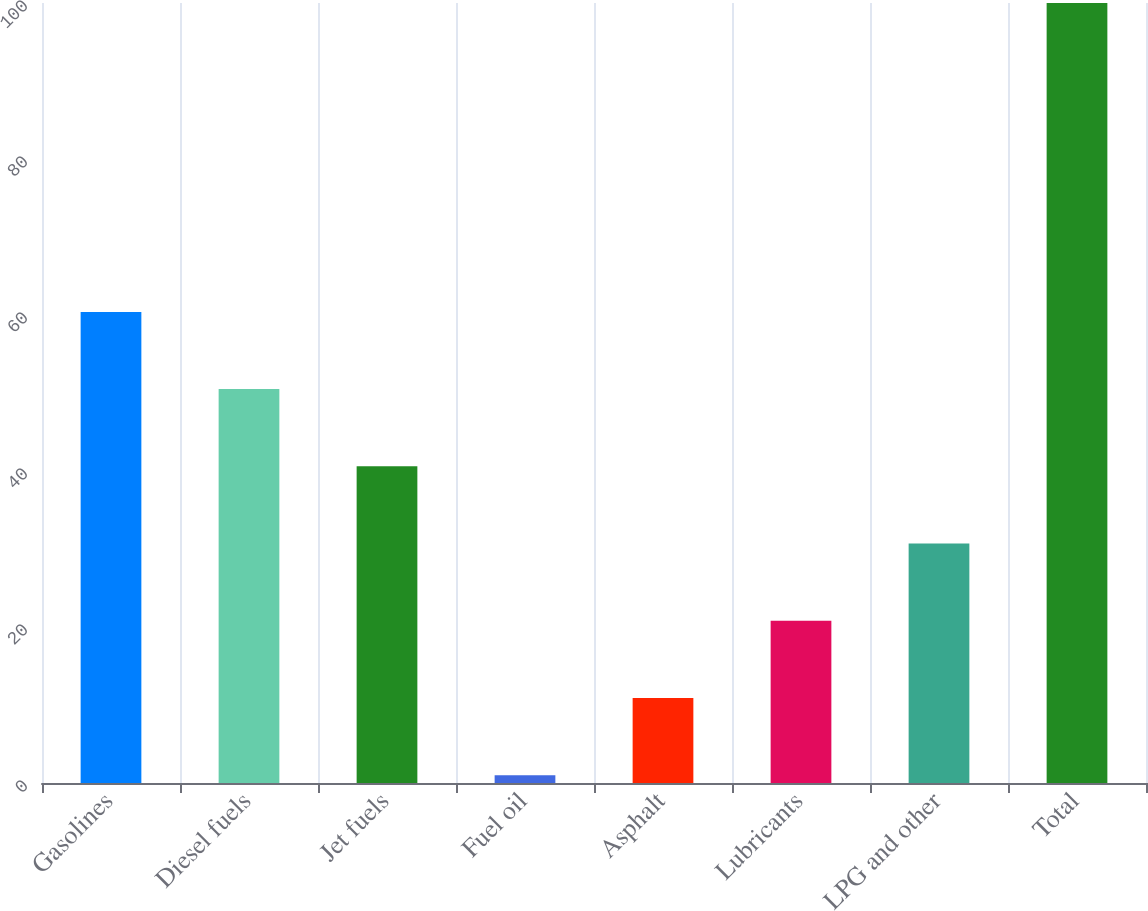Convert chart to OTSL. <chart><loc_0><loc_0><loc_500><loc_500><bar_chart><fcel>Gasolines<fcel>Diesel fuels<fcel>Jet fuels<fcel>Fuel oil<fcel>Asphalt<fcel>Lubricants<fcel>LPG and other<fcel>Total<nl><fcel>60.4<fcel>50.5<fcel>40.6<fcel>1<fcel>10.9<fcel>20.8<fcel>30.7<fcel>100<nl></chart> 